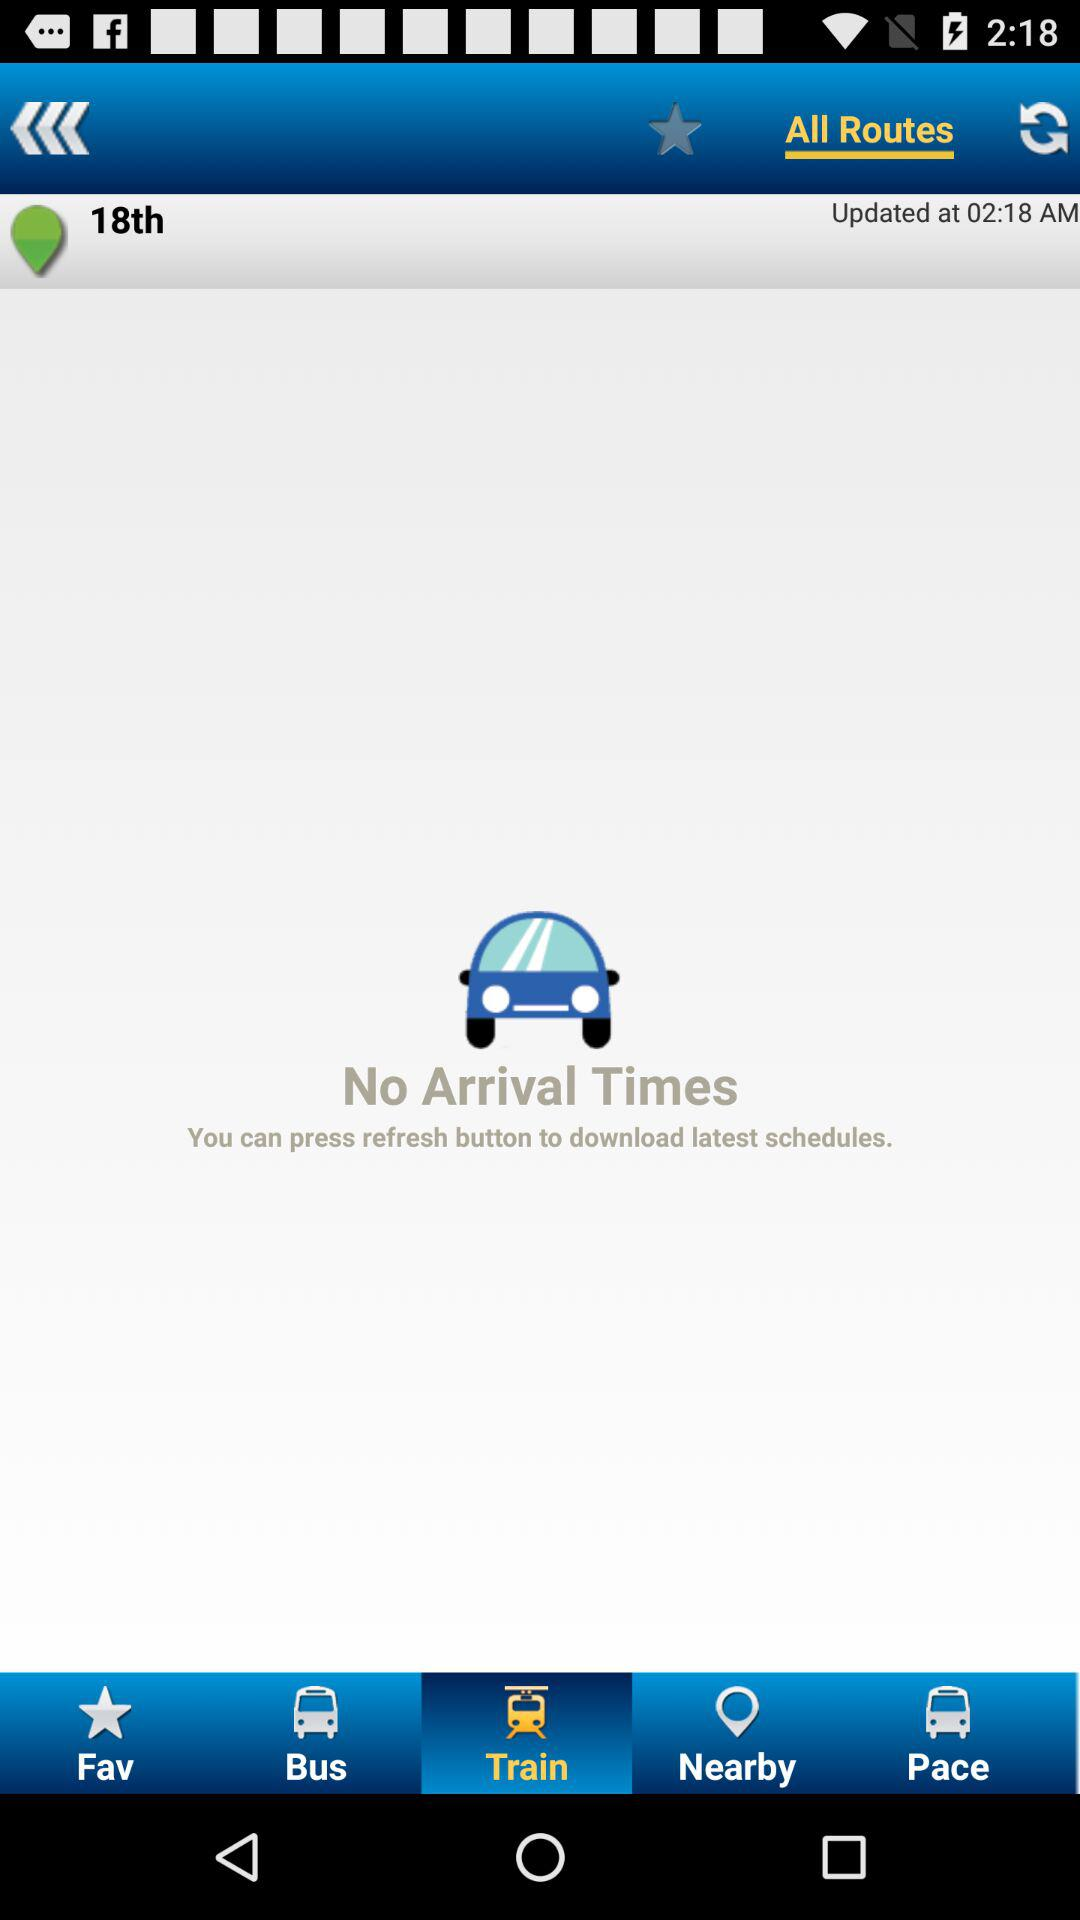What is the updated time? The updated time is 02:18 AM. 